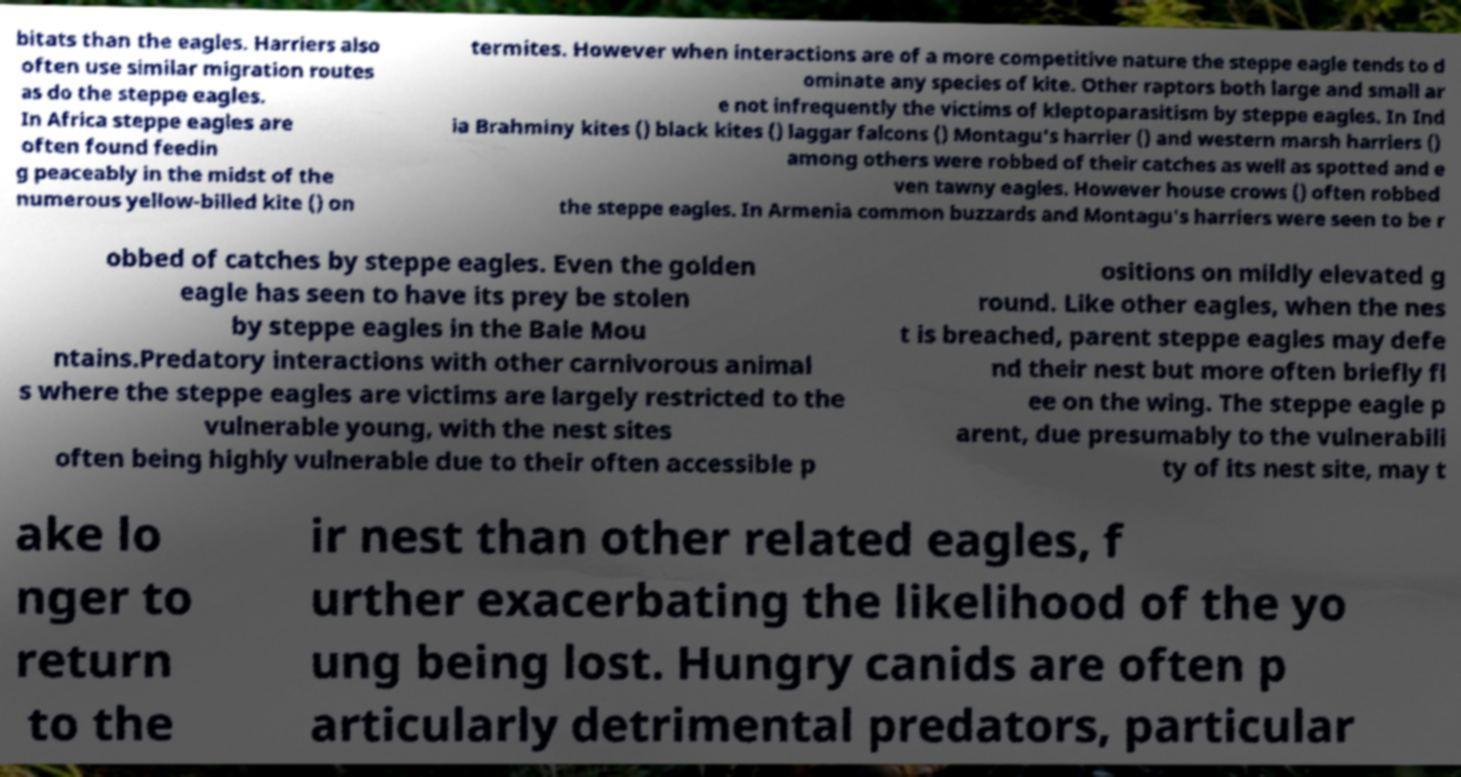Can you accurately transcribe the text from the provided image for me? bitats than the eagles. Harriers also often use similar migration routes as do the steppe eagles. In Africa steppe eagles are often found feedin g peaceably in the midst of the numerous yellow-billed kite () on termites. However when interactions are of a more competitive nature the steppe eagle tends to d ominate any species of kite. Other raptors both large and small ar e not infrequently the victims of kleptoparasitism by steppe eagles. In Ind ia Brahminy kites () black kites () laggar falcons () Montagu's harrier () and western marsh harriers () among others were robbed of their catches as well as spotted and e ven tawny eagles. However house crows () often robbed the steppe eagles. In Armenia common buzzards and Montagu's harriers were seen to be r obbed of catches by steppe eagles. Even the golden eagle has seen to have its prey be stolen by steppe eagles in the Bale Mou ntains.Predatory interactions with other carnivorous animal s where the steppe eagles are victims are largely restricted to the vulnerable young, with the nest sites often being highly vulnerable due to their often accessible p ositions on mildly elevated g round. Like other eagles, when the nes t is breached, parent steppe eagles may defe nd their nest but more often briefly fl ee on the wing. The steppe eagle p arent, due presumably to the vulnerabili ty of its nest site, may t ake lo nger to return to the ir nest than other related eagles, f urther exacerbating the likelihood of the yo ung being lost. Hungry canids are often p articularly detrimental predators, particular 